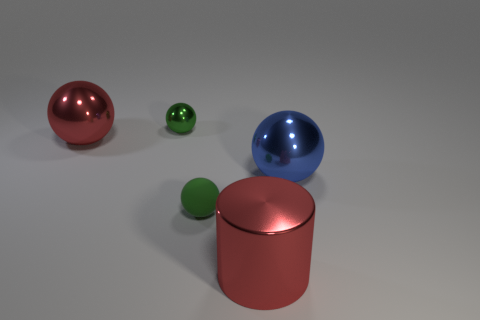Do the shiny object that is in front of the green matte thing and the tiny green matte ball have the same size?
Your answer should be very brief. No. There is a metallic cylinder; is it the same color as the big object that is behind the big blue metal object?
Give a very brief answer. Yes. There is a thing that is the same color as the matte ball; what is its material?
Give a very brief answer. Metal. There is a green rubber sphere; how many big red things are to the left of it?
Your answer should be very brief. 1. What material is the tiny ball that is behind the big shiny ball to the right of the big metal cylinder made of?
Ensure brevity in your answer.  Metal. There is a green object that is the same size as the matte sphere; what material is it?
Offer a terse response. Metal. Are there any green spheres of the same size as the blue metal sphere?
Your answer should be very brief. No. The tiny thing that is in front of the blue metallic object is what color?
Your response must be concise. Green. Is there a blue thing that is behind the red thing to the left of the red metal cylinder?
Offer a terse response. No. How many other objects are the same color as the big cylinder?
Offer a very short reply. 1. 